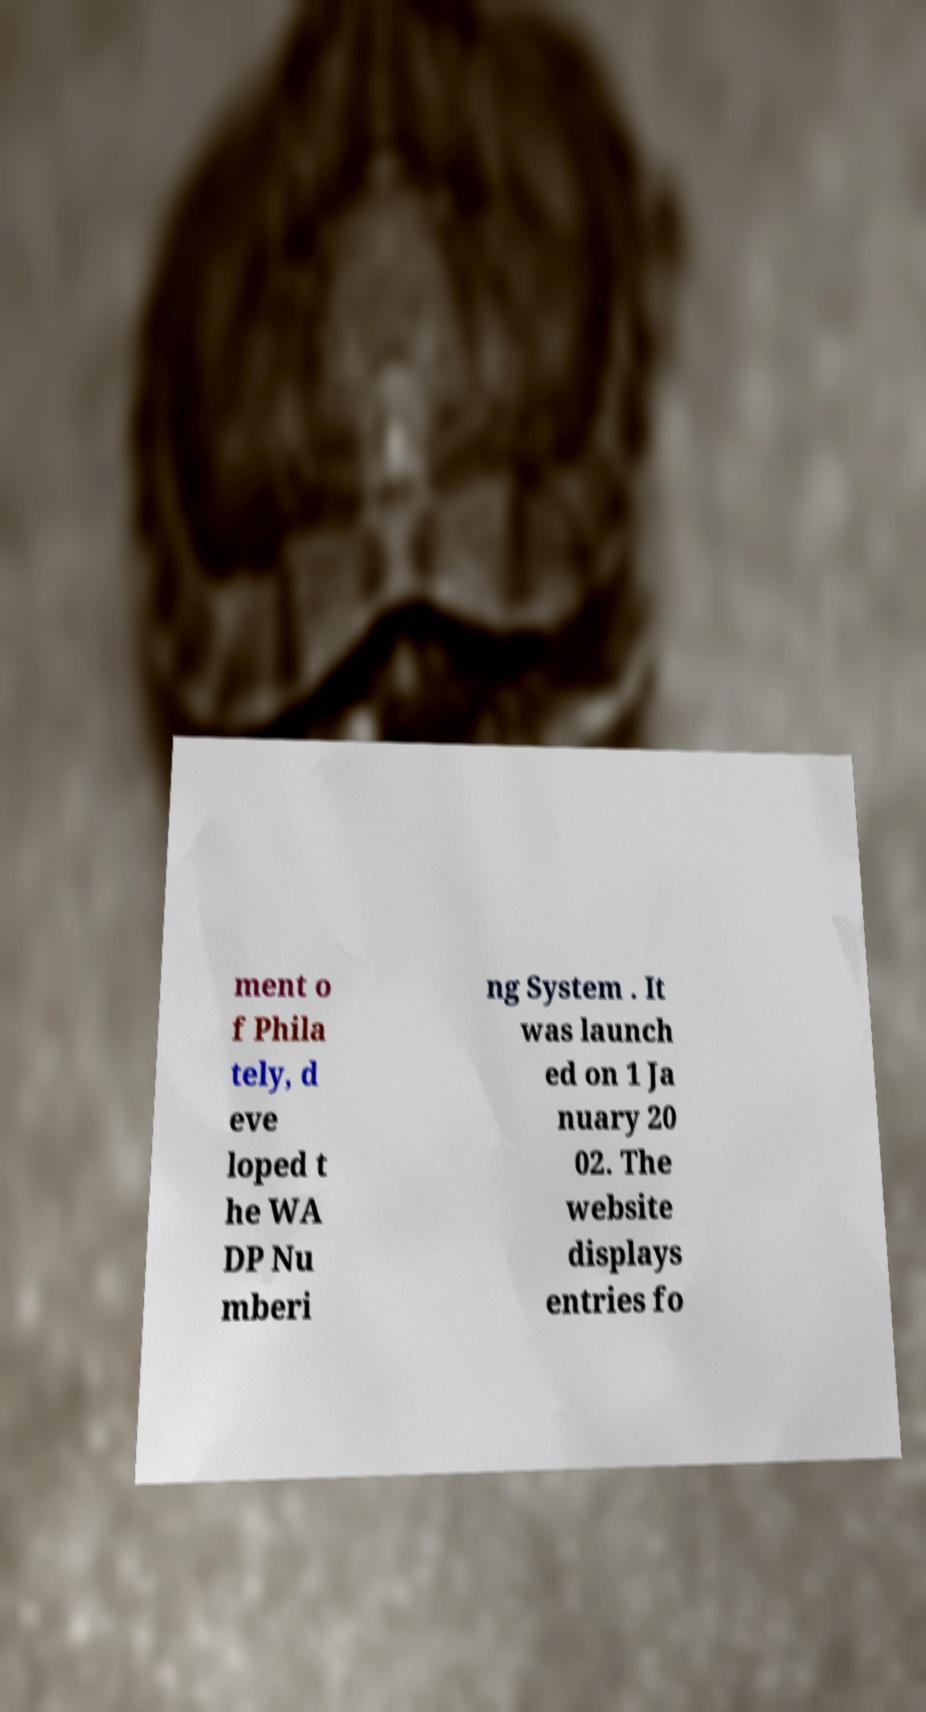For documentation purposes, I need the text within this image transcribed. Could you provide that? ment o f Phila tely, d eve loped t he WA DP Nu mberi ng System . It was launch ed on 1 Ja nuary 20 02. The website displays entries fo 